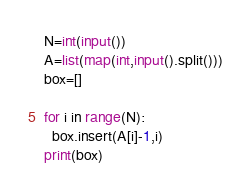Convert code to text. <code><loc_0><loc_0><loc_500><loc_500><_Python_>N=int(input())
A=list(map(int,input().split()))
box=[]

for i in range(N):
  box.insert(A[i]-1,i)
print(box)</code> 